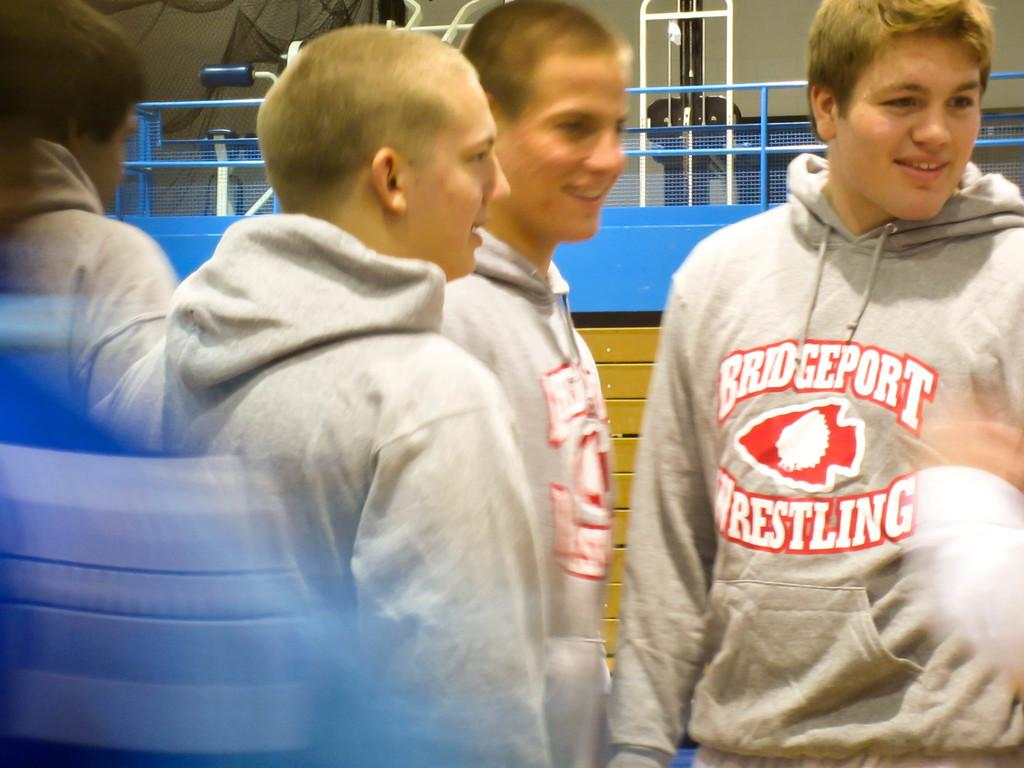<image>
Share a concise interpretation of the image provided. Bunch of Men wearing Bridgeport Wrestling Sweatshirts, that are smiling. 